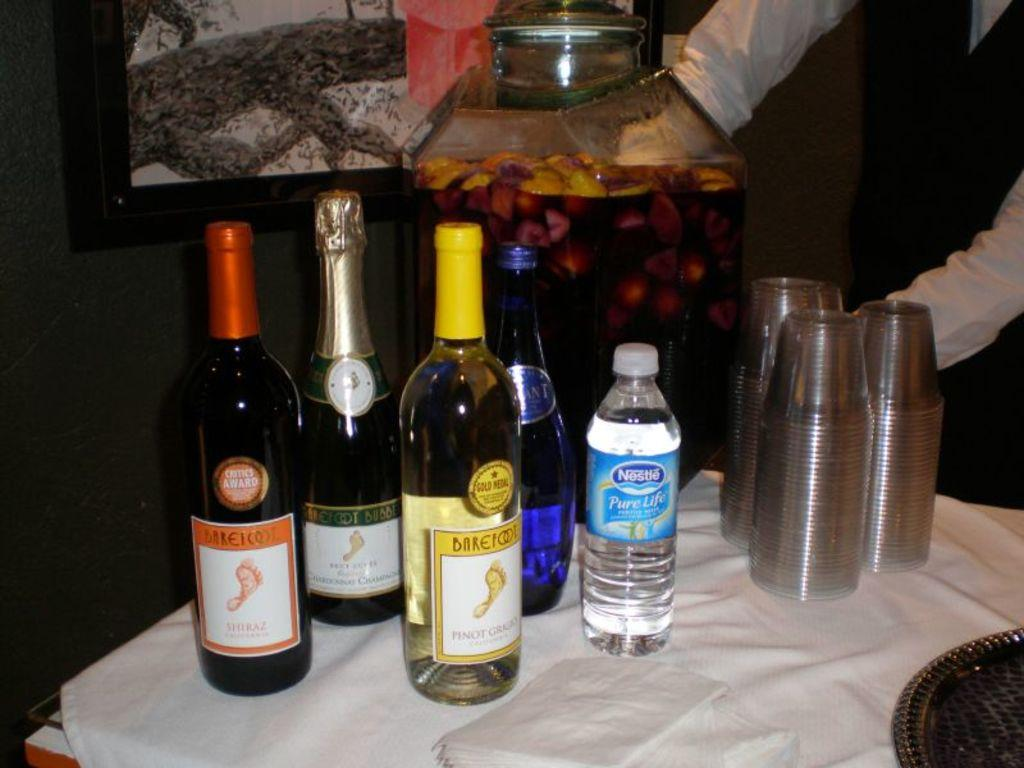<image>
Describe the image concisely. Several bottles of Barefoot wine sitting on a table next to nestle purelife water and cups. 